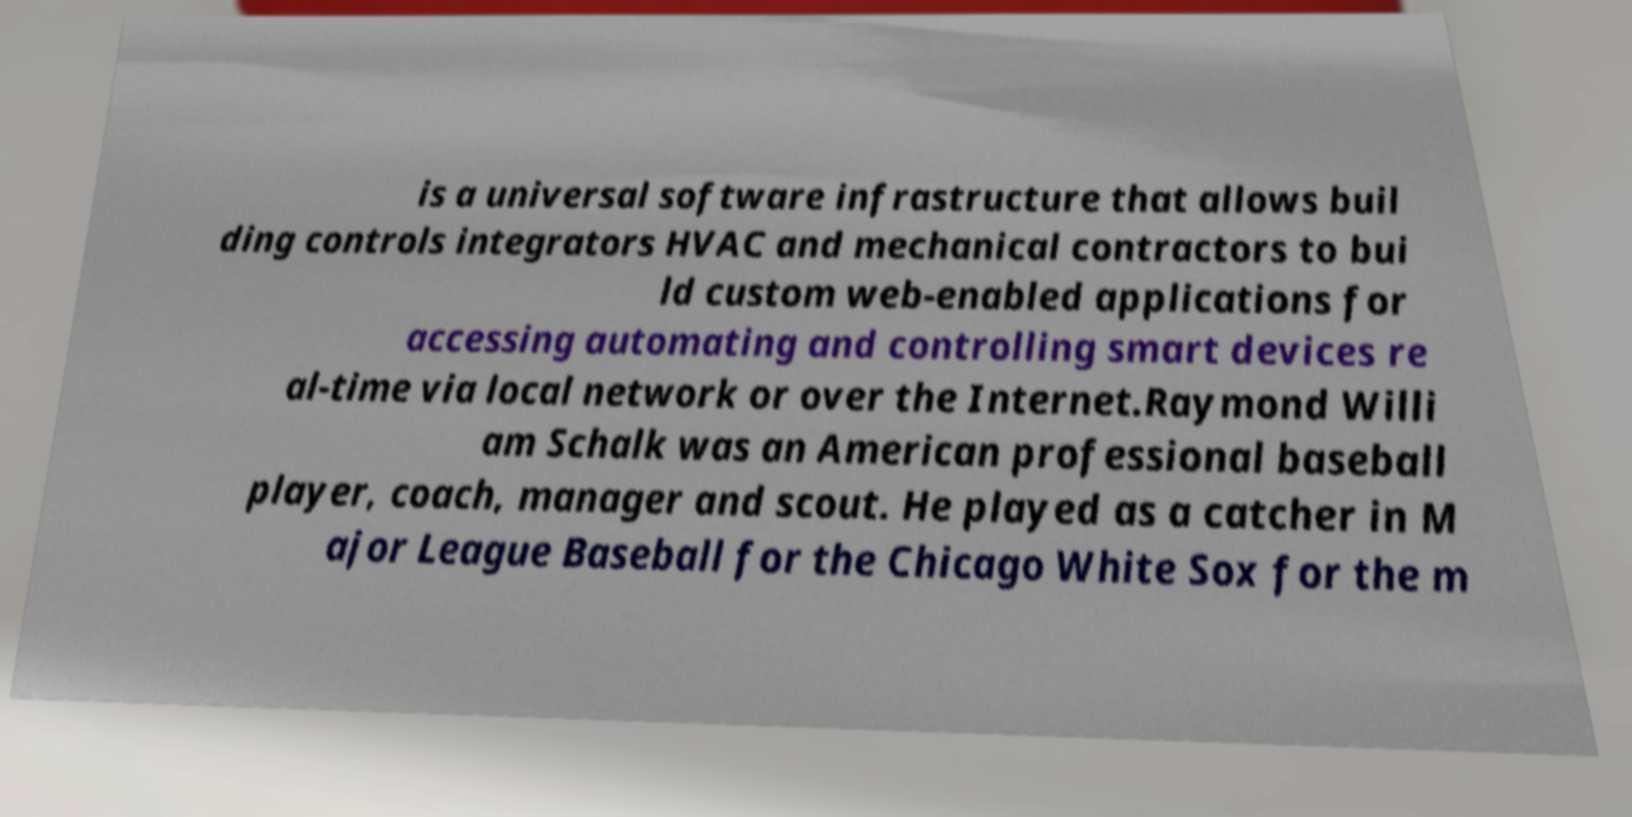There's text embedded in this image that I need extracted. Can you transcribe it verbatim? is a universal software infrastructure that allows buil ding controls integrators HVAC and mechanical contractors to bui ld custom web-enabled applications for accessing automating and controlling smart devices re al-time via local network or over the Internet.Raymond Willi am Schalk was an American professional baseball player, coach, manager and scout. He played as a catcher in M ajor League Baseball for the Chicago White Sox for the m 